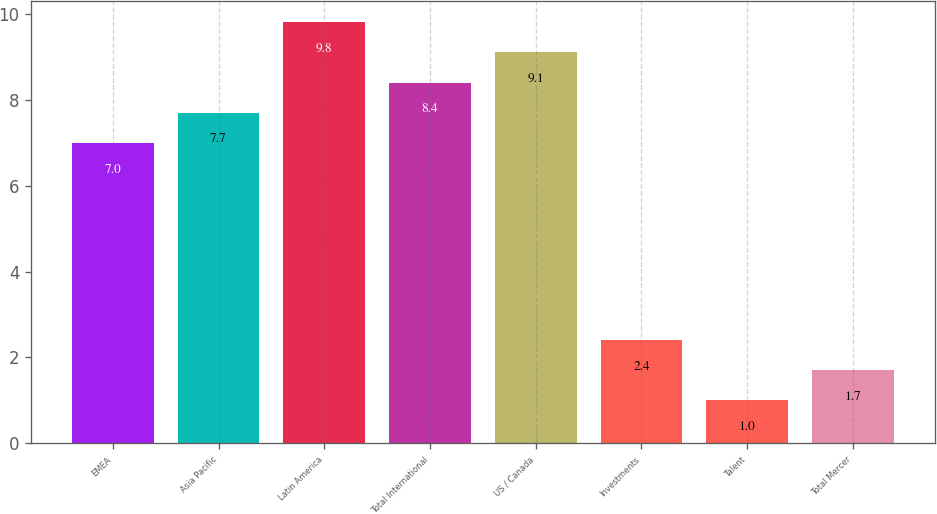Convert chart to OTSL. <chart><loc_0><loc_0><loc_500><loc_500><bar_chart><fcel>EMEA<fcel>Asia Pacific<fcel>Latin America<fcel>Total International<fcel>US / Canada<fcel>Investments<fcel>Talent<fcel>Total Mercer<nl><fcel>7<fcel>7.7<fcel>9.8<fcel>8.4<fcel>9.1<fcel>2.4<fcel>1<fcel>1.7<nl></chart> 